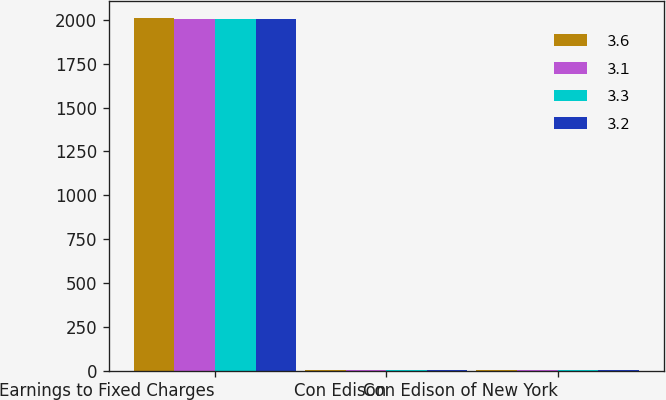Convert chart to OTSL. <chart><loc_0><loc_0><loc_500><loc_500><stacked_bar_chart><ecel><fcel>Earnings to Fixed Charges<fcel>Con Edison<fcel>Con Edison of New York<nl><fcel>3.6<fcel>2008<fcel>3.4<fcel>3.3<nl><fcel>3.1<fcel>2007<fcel>3.4<fcel>3.6<nl><fcel>3.3<fcel>2006<fcel>3<fcel>3.2<nl><fcel>3.2<fcel>2004<fcel>2.8<fcel>3.1<nl></chart> 